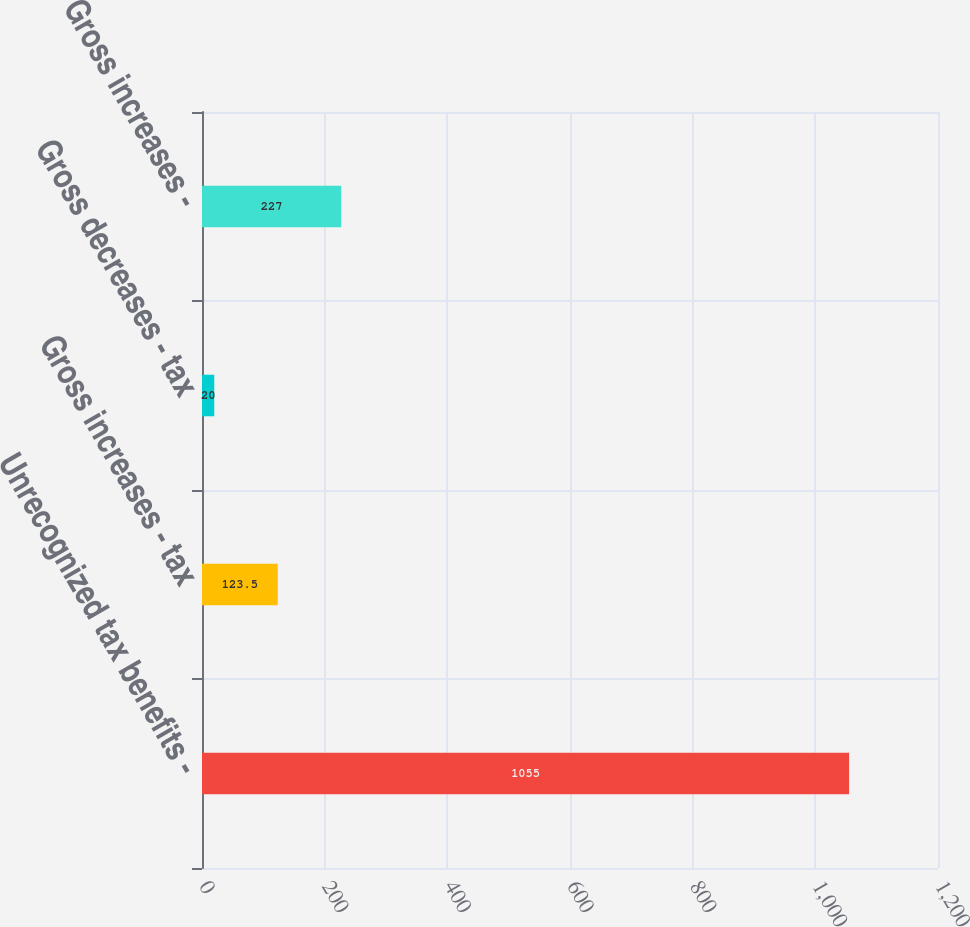Convert chart. <chart><loc_0><loc_0><loc_500><loc_500><bar_chart><fcel>Unrecognized tax benefits -<fcel>Gross increases - tax<fcel>Gross decreases - tax<fcel>Gross increases -<nl><fcel>1055<fcel>123.5<fcel>20<fcel>227<nl></chart> 